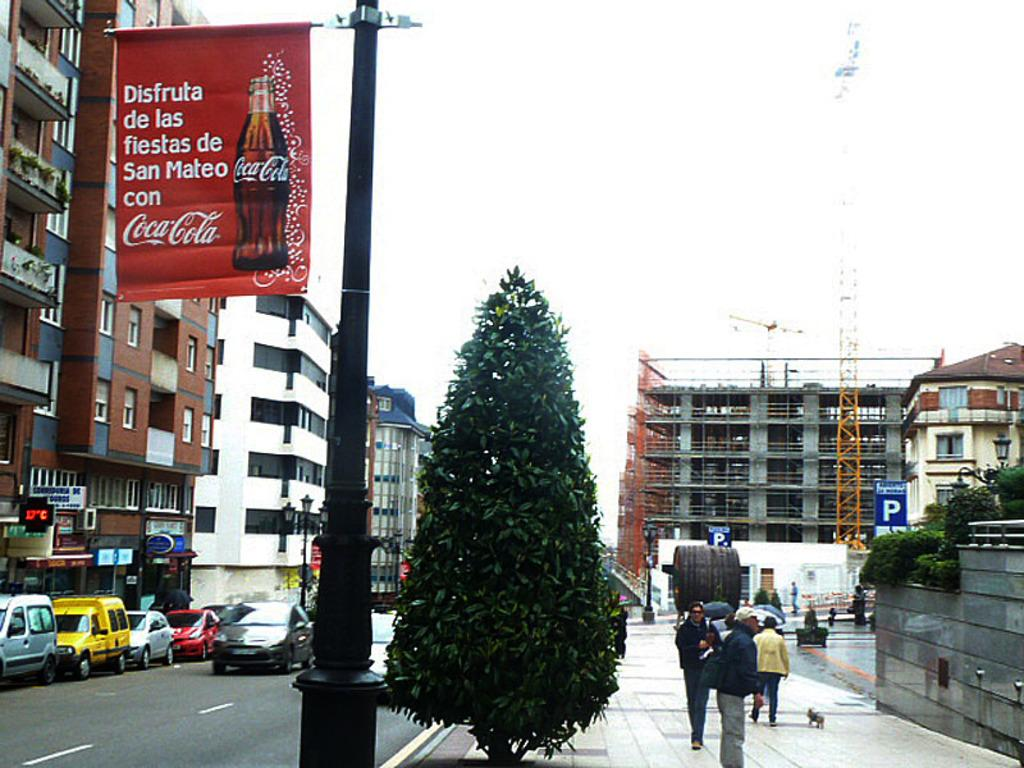<image>
Relay a brief, clear account of the picture shown. A Coca Cola banner attached to a light pole references the city of San Mateo. 